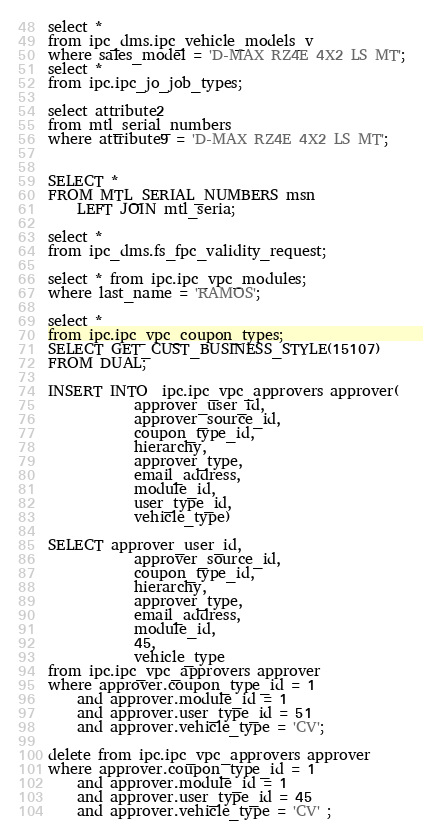Convert code to text. <code><loc_0><loc_0><loc_500><loc_500><_SQL_>select *
from ipc_dms.ipc_vehicle_models_v
where sales_model = 'D-MAX RZ4E 4X2 LS MT';
select *
from ipc.ipc_jo_job_types;

select attribute2 
from mtl_serial_numbers
where attribute9 = 'D-MAX RZ4E 4X2 LS MT';


SELECT *
FROM MTL_SERIAL_NUMBERS msn
    LEFT JOIN mtl_seria;

select *
from ipc_dms.fs_fpc_validity_request;

select * from ipc.ipc_vpc_modules;
where last_name = 'RAMOS';
 
select *
from ipc.ipc_vpc_coupon_types;
SELECT GET_CUST_BUSINESS_STYLE(15107)
FROM DUAL;

INSERT INTO  ipc.ipc_vpc_approvers approver(
            approver_user_id, 
            approver_source_id,
            coupon_type_id,
            hierarchy,
            approver_type,
            email_address,
            module_id,
            user_type_id,
            vehicle_type) 

SELECT approver_user_id, 
            approver_source_id,
            coupon_type_id,
            hierarchy,
            approver_type,
            email_address,
            module_id,
            45,
            vehicle_type
from ipc.ipc_vpc_approvers approver
where approver.coupon_type_id = 1
    and approver.module_id = 1
    and approver.user_type_id = 51
    and approver.vehicle_type = 'CV';

delete from ipc.ipc_vpc_approvers approver
where approver.coupon_type_id = 1
    and approver.module_id = 1
    and approver.user_type_id = 45
    and approver.vehicle_type = 'CV' ;
</code> 